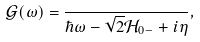<formula> <loc_0><loc_0><loc_500><loc_500>\mathcal { G } ( \omega ) = \frac { } { \hbar { \omega } - \sqrt { 2 } \mathcal { H } _ { 0 - } + i \eta } ,</formula> 